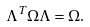Convert formula to latex. <formula><loc_0><loc_0><loc_500><loc_500>\Lambda ^ { T } \Omega \Lambda = \Omega .</formula> 